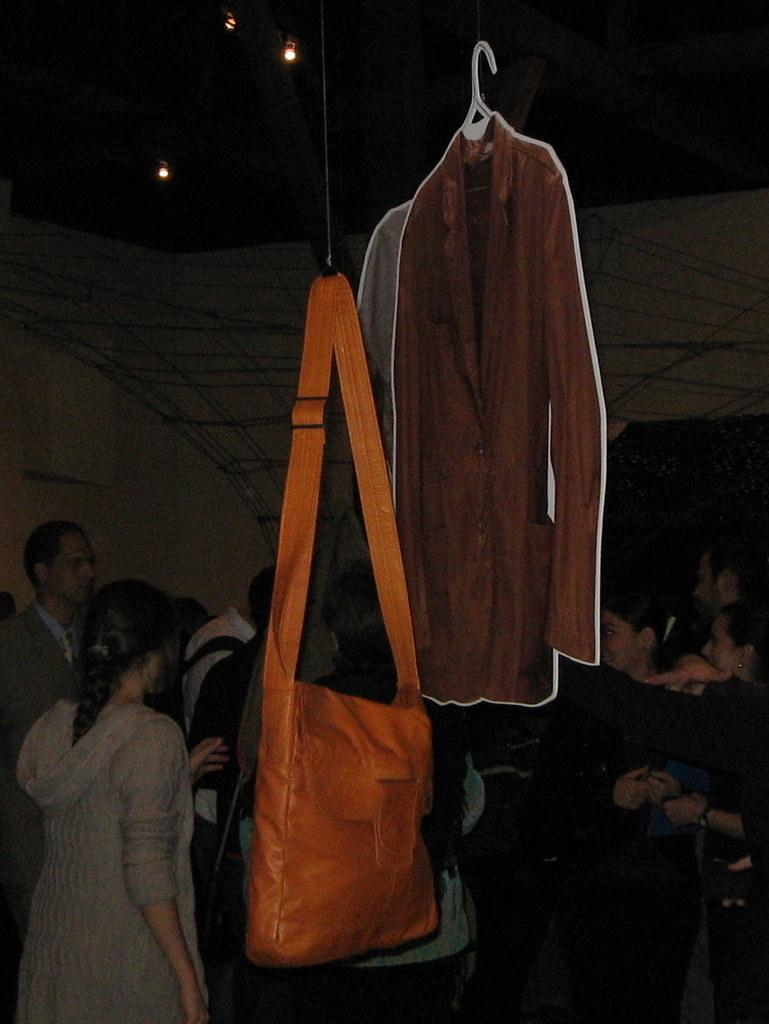Who or what can be seen in the image? There are people in the image. What object is hanging in the image? There is a bag hanging in the image. What can be seen at the top of the image? There are lights visible at the top of the image. What type of hot flame can be seen near the people in the image? There is no hot flame present in the image. 